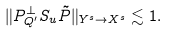<formula> <loc_0><loc_0><loc_500><loc_500>\| P ^ { \perp } _ { Q ^ { \prime } } S _ { u } \tilde { P } \| _ { Y ^ { s } \to X ^ { s } } \lesssim 1 .</formula> 